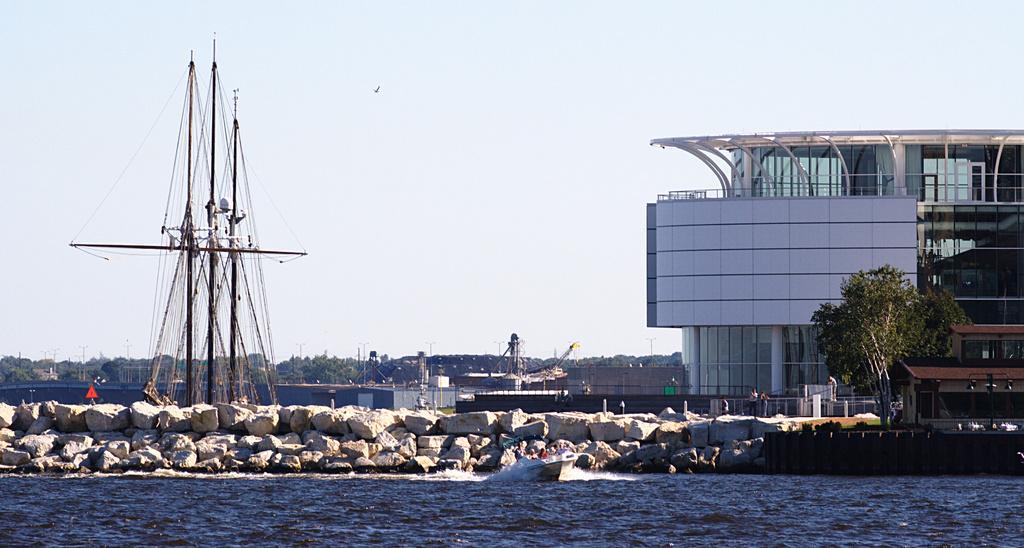How would you summarize this image in a sentence or two? In this image I can see the water in blue color. To the side of the water I can see many rocks and railing. In the background I can see the poles, many trees and the building. I can also see the sky in the back. 